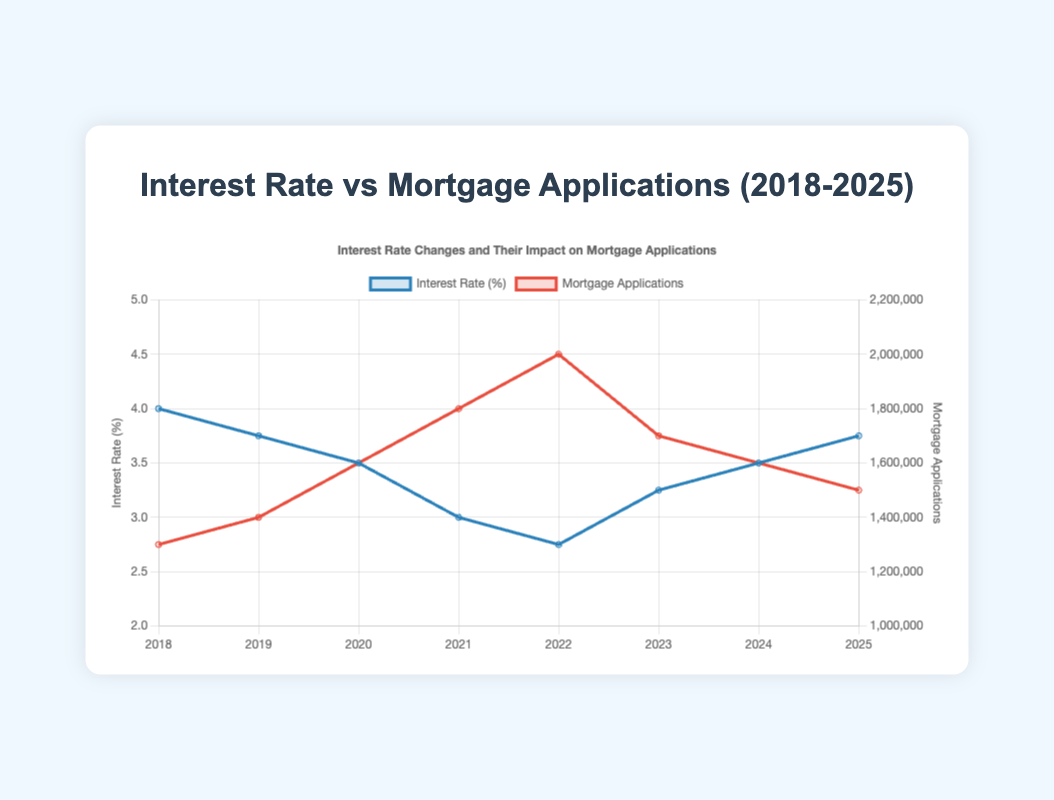What is the trend between interest rates and mortgage applications from 2018 to 2022? The figure shows that from 2018 to 2022, as the interest rates decrease from 4.0% to 2.75%, the number of mortgage applications increases from 1.3 million to 2 million.
Answer: Decreasing interest rates correlate with increasing mortgage applications In which year did the mortgage applications peak, and what was the interest rate that year? The highest number of mortgage applications occurred in 2022 with 2 million applications when the interest rate was 2.75%.
Answer: 2022, 2.75% How did the interest rate change from 2021 to 2022, and what was the resulting change in mortgage applications? The interest rate decreased from 3.0% in 2021 to 2.75% in 2022, resulting in an increase in mortgage applications from 1.8 million to 2 million.
Answer: Decreased by 0.25% leading to an increase of 200,000 applications What is the relationship between the trend of interest rates and mortgage applications from 2022 to 2025? After 2022, the interest rate increases from 2.75% in 2022 to 3.75% in 2025, while mortgage applications decrease from 2 million in 2022 to 1.5 million in 2025.
Answer: Increasing interest rates correlate with decreasing mortgage applications Compare the interest rate and mortgage applications between 2020 and 2023. In 2020, the interest rate was 3.5%, and there were 1.6 million mortgage applications. In 2023, the interest rate was 3.25%, and there were 1.7 million mortgage applications.
Answer: 2020: 3.5%, 1.6 million; 2023: 3.25%, 1.7 million What is the average interest rate from 2018 to 2025? Add the annual interest rates: 4.0 + 3.75 + 3.5 + 3.0 + 2.75 + 3.25 + 3.5 + 3.75 = 27.5, then divide by the number of years (8): 27.5 / 8 = 3.44%
Answer: 3.44% Which year had the smallest difference between interest rate and mortgage applications? Calculate the absolute difference for each year, for example, for 2018:
Answer: The smallest difference is in 2018 What visual attributes distinguish the interest rate and mortgage application lines in the chart? The interest rate line is marked with a blue color, while the mortgage applications line is marked with a red color. The interest rate line uses the left y-axis, while the mortgage applications line uses the right y-axis.
Answer: Blue for interest rate, red for mortgage applications What is the overall trend in mortgage applications from 2018 to 2025? Initially, there is an increasing trend in mortgage applications from 2018 to 2022, followed by a decreasing trend from 2023 to 2025.
Answer: Increase until 2022, then decrease 